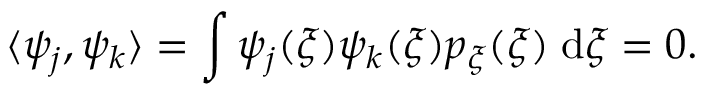<formula> <loc_0><loc_0><loc_500><loc_500>\langle \psi _ { j } , \psi _ { k } \rangle = \int \psi _ { j } ( \xi ) \psi _ { k } ( \xi ) p _ { \xi } ( \xi ) \, d \xi = 0 .</formula> 